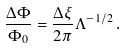Convert formula to latex. <formula><loc_0><loc_0><loc_500><loc_500>\frac { \Delta \Phi } { \Phi _ { 0 } } = \frac { \Delta \xi } { 2 \pi } \Lambda ^ { - 1 / 2 } \, .</formula> 